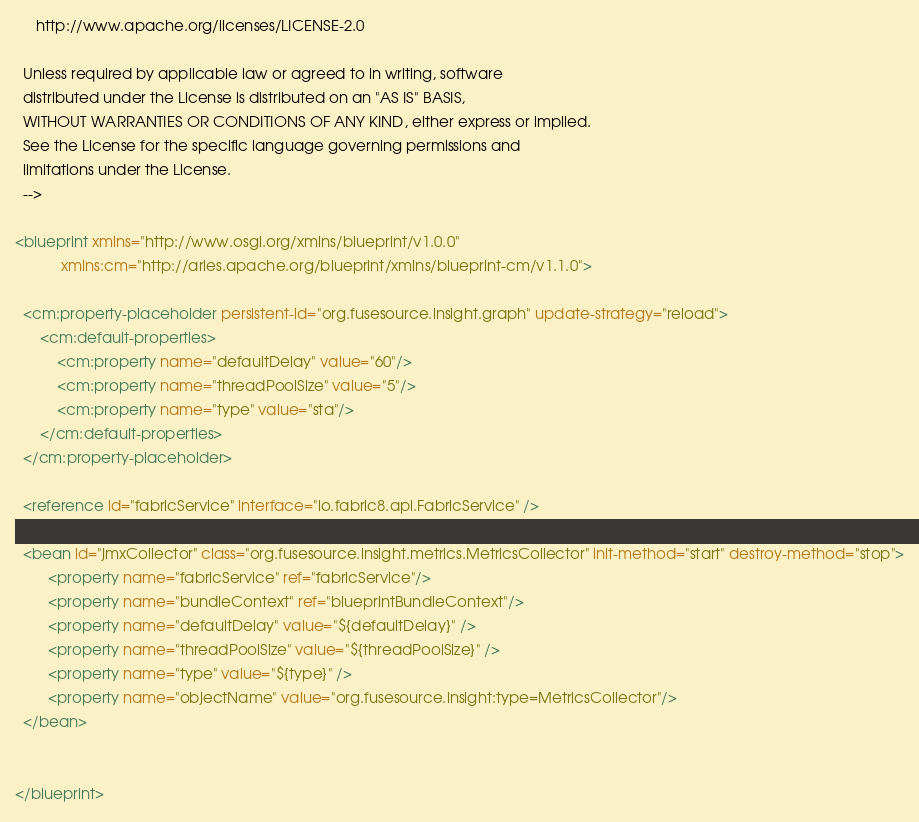Convert code to text. <code><loc_0><loc_0><loc_500><loc_500><_XML_>
     http://www.apache.org/licenses/LICENSE-2.0

  Unless required by applicable law or agreed to in writing, software
  distributed under the License is distributed on an "AS IS" BASIS,
  WITHOUT WARRANTIES OR CONDITIONS OF ANY KIND, either express or implied.
  See the License for the specific language governing permissions and
  limitations under the License.
  -->

<blueprint xmlns="http://www.osgi.org/xmlns/blueprint/v1.0.0"
           xmlns:cm="http://aries.apache.org/blueprint/xmlns/blueprint-cm/v1.1.0">

  <cm:property-placeholder persistent-id="org.fusesource.insight.graph" update-strategy="reload">
      <cm:default-properties>
          <cm:property name="defaultDelay" value="60"/>
          <cm:property name="threadPoolSize" value="5"/>
          <cm:property name="type" value="sta"/>
      </cm:default-properties>
  </cm:property-placeholder>

  <reference id="fabricService" interface="io.fabric8.api.FabricService" />

  <bean id="jmxCollector" class="org.fusesource.insight.metrics.MetricsCollector" init-method="start" destroy-method="stop">
        <property name="fabricService" ref="fabricService"/>
        <property name="bundleContext" ref="blueprintBundleContext"/>
        <property name="defaultDelay" value="${defaultDelay}" />
        <property name="threadPoolSize" value="${threadPoolSize}" />
        <property name="type" value="${type}" />
        <property name="objectName" value="org.fusesource.insight:type=MetricsCollector"/>
  </bean>


</blueprint></code> 